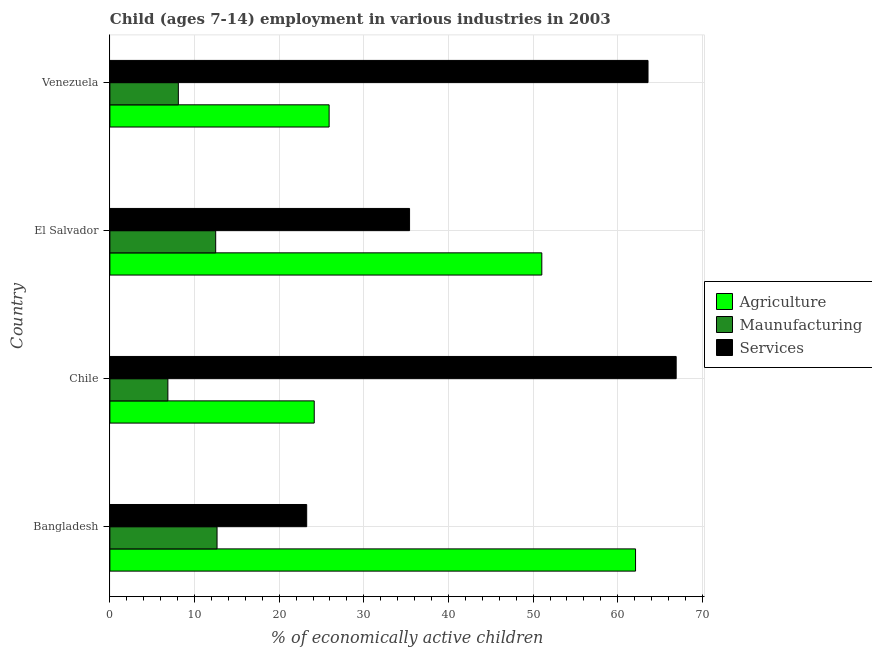Are the number of bars per tick equal to the number of legend labels?
Ensure brevity in your answer.  Yes. How many bars are there on the 4th tick from the top?
Your response must be concise. 3. How many bars are there on the 4th tick from the bottom?
Ensure brevity in your answer.  3. In how many cases, is the number of bars for a given country not equal to the number of legend labels?
Ensure brevity in your answer.  0. What is the percentage of economically active children in manufacturing in Bangladesh?
Give a very brief answer. 12.66. Across all countries, what is the maximum percentage of economically active children in services?
Make the answer very short. 66.9. Across all countries, what is the minimum percentage of economically active children in manufacturing?
Your answer should be compact. 6.85. In which country was the percentage of economically active children in agriculture minimum?
Ensure brevity in your answer.  Chile. What is the total percentage of economically active children in services in the graph?
Give a very brief answer. 189.13. What is the difference between the percentage of economically active children in agriculture in Bangladesh and that in Venezuela?
Offer a terse response. 36.2. What is the difference between the percentage of economically active children in agriculture in Venezuela and the percentage of economically active children in services in El Salvador?
Your answer should be compact. -9.5. What is the average percentage of economically active children in manufacturing per country?
Offer a very short reply. 10.02. What is the difference between the percentage of economically active children in agriculture and percentage of economically active children in manufacturing in El Salvador?
Your answer should be compact. 38.53. What is the ratio of the percentage of economically active children in services in Bangladesh to that in Chile?
Your answer should be compact. 0.35. Is the percentage of economically active children in agriculture in Chile less than that in Venezuela?
Make the answer very short. Yes. Is the difference between the percentage of economically active children in agriculture in Chile and El Salvador greater than the difference between the percentage of economically active children in services in Chile and El Salvador?
Your answer should be very brief. No. What is the difference between the highest and the second highest percentage of economically active children in services?
Make the answer very short. 3.33. What is the difference between the highest and the lowest percentage of economically active children in agriculture?
Give a very brief answer. 37.96. What does the 3rd bar from the top in Venezuela represents?
Your response must be concise. Agriculture. What does the 2nd bar from the bottom in El Salvador represents?
Your response must be concise. Maunufacturing. How many bars are there?
Your answer should be very brief. 12. Are all the bars in the graph horizontal?
Offer a terse response. Yes. Are the values on the major ticks of X-axis written in scientific E-notation?
Make the answer very short. No. Does the graph contain grids?
Your answer should be very brief. Yes. How are the legend labels stacked?
Give a very brief answer. Vertical. What is the title of the graph?
Provide a short and direct response. Child (ages 7-14) employment in various industries in 2003. Does "Transport" appear as one of the legend labels in the graph?
Provide a succinct answer. No. What is the label or title of the X-axis?
Keep it short and to the point. % of economically active children. What is the % of economically active children in Agriculture in Bangladesh?
Give a very brief answer. 62.1. What is the % of economically active children in Maunufacturing in Bangladesh?
Offer a very short reply. 12.66. What is the % of economically active children of Services in Bangladesh?
Make the answer very short. 23.25. What is the % of economically active children in Agriculture in Chile?
Provide a short and direct response. 24.14. What is the % of economically active children in Maunufacturing in Chile?
Provide a succinct answer. 6.85. What is the % of economically active children of Services in Chile?
Give a very brief answer. 66.9. What is the % of economically active children of Agriculture in El Salvador?
Provide a succinct answer. 51.03. What is the % of economically active children of Maunufacturing in El Salvador?
Your answer should be very brief. 12.5. What is the % of economically active children in Services in El Salvador?
Give a very brief answer. 35.4. What is the % of economically active children in Agriculture in Venezuela?
Provide a short and direct response. 25.9. What is the % of economically active children of Maunufacturing in Venezuela?
Your response must be concise. 8.09. What is the % of economically active children in Services in Venezuela?
Provide a short and direct response. 63.57. Across all countries, what is the maximum % of economically active children of Agriculture?
Your answer should be very brief. 62.1. Across all countries, what is the maximum % of economically active children in Maunufacturing?
Give a very brief answer. 12.66. Across all countries, what is the maximum % of economically active children of Services?
Your answer should be very brief. 66.9. Across all countries, what is the minimum % of economically active children in Agriculture?
Offer a terse response. 24.14. Across all countries, what is the minimum % of economically active children of Maunufacturing?
Your answer should be compact. 6.85. Across all countries, what is the minimum % of economically active children of Services?
Make the answer very short. 23.25. What is the total % of economically active children in Agriculture in the graph?
Offer a terse response. 163.17. What is the total % of economically active children of Maunufacturing in the graph?
Offer a very short reply. 40.1. What is the total % of economically active children in Services in the graph?
Offer a terse response. 189.13. What is the difference between the % of economically active children in Agriculture in Bangladesh and that in Chile?
Offer a very short reply. 37.96. What is the difference between the % of economically active children in Maunufacturing in Bangladesh and that in Chile?
Your response must be concise. 5.81. What is the difference between the % of economically active children of Services in Bangladesh and that in Chile?
Ensure brevity in your answer.  -43.65. What is the difference between the % of economically active children in Agriculture in Bangladesh and that in El Salvador?
Provide a succinct answer. 11.07. What is the difference between the % of economically active children of Maunufacturing in Bangladesh and that in El Salvador?
Ensure brevity in your answer.  0.16. What is the difference between the % of economically active children of Services in Bangladesh and that in El Salvador?
Provide a short and direct response. -12.15. What is the difference between the % of economically active children in Agriculture in Bangladesh and that in Venezuela?
Offer a terse response. 36.2. What is the difference between the % of economically active children of Maunufacturing in Bangladesh and that in Venezuela?
Your response must be concise. 4.57. What is the difference between the % of economically active children in Services in Bangladesh and that in Venezuela?
Offer a very short reply. -40.32. What is the difference between the % of economically active children of Agriculture in Chile and that in El Salvador?
Your response must be concise. -26.89. What is the difference between the % of economically active children in Maunufacturing in Chile and that in El Salvador?
Provide a succinct answer. -5.65. What is the difference between the % of economically active children of Services in Chile and that in El Salvador?
Provide a short and direct response. 31.5. What is the difference between the % of economically active children of Agriculture in Chile and that in Venezuela?
Keep it short and to the point. -1.76. What is the difference between the % of economically active children of Maunufacturing in Chile and that in Venezuela?
Make the answer very short. -1.24. What is the difference between the % of economically active children of Services in Chile and that in Venezuela?
Provide a succinct answer. 3.33. What is the difference between the % of economically active children in Agriculture in El Salvador and that in Venezuela?
Offer a terse response. 25.13. What is the difference between the % of economically active children in Maunufacturing in El Salvador and that in Venezuela?
Your answer should be very brief. 4.41. What is the difference between the % of economically active children in Services in El Salvador and that in Venezuela?
Provide a succinct answer. -28.17. What is the difference between the % of economically active children of Agriculture in Bangladesh and the % of economically active children of Maunufacturing in Chile?
Your answer should be compact. 55.25. What is the difference between the % of economically active children in Agriculture in Bangladesh and the % of economically active children in Services in Chile?
Keep it short and to the point. -4.8. What is the difference between the % of economically active children in Maunufacturing in Bangladesh and the % of economically active children in Services in Chile?
Offer a terse response. -54.24. What is the difference between the % of economically active children of Agriculture in Bangladesh and the % of economically active children of Maunufacturing in El Salvador?
Offer a very short reply. 49.6. What is the difference between the % of economically active children in Agriculture in Bangladesh and the % of economically active children in Services in El Salvador?
Provide a succinct answer. 26.7. What is the difference between the % of economically active children of Maunufacturing in Bangladesh and the % of economically active children of Services in El Salvador?
Give a very brief answer. -22.74. What is the difference between the % of economically active children of Agriculture in Bangladesh and the % of economically active children of Maunufacturing in Venezuela?
Give a very brief answer. 54.01. What is the difference between the % of economically active children of Agriculture in Bangladesh and the % of economically active children of Services in Venezuela?
Keep it short and to the point. -1.47. What is the difference between the % of economically active children in Maunufacturing in Bangladesh and the % of economically active children in Services in Venezuela?
Provide a succinct answer. -50.91. What is the difference between the % of economically active children in Agriculture in Chile and the % of economically active children in Maunufacturing in El Salvador?
Provide a succinct answer. 11.64. What is the difference between the % of economically active children of Agriculture in Chile and the % of economically active children of Services in El Salvador?
Provide a short and direct response. -11.26. What is the difference between the % of economically active children in Maunufacturing in Chile and the % of economically active children in Services in El Salvador?
Offer a very short reply. -28.55. What is the difference between the % of economically active children of Agriculture in Chile and the % of economically active children of Maunufacturing in Venezuela?
Your answer should be compact. 16.05. What is the difference between the % of economically active children in Agriculture in Chile and the % of economically active children in Services in Venezuela?
Ensure brevity in your answer.  -39.43. What is the difference between the % of economically active children in Maunufacturing in Chile and the % of economically active children in Services in Venezuela?
Offer a very short reply. -56.72. What is the difference between the % of economically active children in Agriculture in El Salvador and the % of economically active children in Maunufacturing in Venezuela?
Offer a very short reply. 42.94. What is the difference between the % of economically active children of Agriculture in El Salvador and the % of economically active children of Services in Venezuela?
Make the answer very short. -12.55. What is the difference between the % of economically active children of Maunufacturing in El Salvador and the % of economically active children of Services in Venezuela?
Give a very brief answer. -51.07. What is the average % of economically active children of Agriculture per country?
Provide a short and direct response. 40.79. What is the average % of economically active children of Maunufacturing per country?
Provide a short and direct response. 10.02. What is the average % of economically active children in Services per country?
Provide a short and direct response. 47.28. What is the difference between the % of economically active children of Agriculture and % of economically active children of Maunufacturing in Bangladesh?
Make the answer very short. 49.44. What is the difference between the % of economically active children in Agriculture and % of economically active children in Services in Bangladesh?
Make the answer very short. 38.85. What is the difference between the % of economically active children in Maunufacturing and % of economically active children in Services in Bangladesh?
Offer a very short reply. -10.59. What is the difference between the % of economically active children of Agriculture and % of economically active children of Maunufacturing in Chile?
Make the answer very short. 17.29. What is the difference between the % of economically active children in Agriculture and % of economically active children in Services in Chile?
Ensure brevity in your answer.  -42.76. What is the difference between the % of economically active children in Maunufacturing and % of economically active children in Services in Chile?
Your answer should be compact. -60.05. What is the difference between the % of economically active children in Agriculture and % of economically active children in Maunufacturing in El Salvador?
Your answer should be compact. 38.53. What is the difference between the % of economically active children of Agriculture and % of economically active children of Services in El Salvador?
Provide a succinct answer. 15.62. What is the difference between the % of economically active children of Maunufacturing and % of economically active children of Services in El Salvador?
Give a very brief answer. -22.9. What is the difference between the % of economically active children of Agriculture and % of economically active children of Maunufacturing in Venezuela?
Your answer should be very brief. 17.81. What is the difference between the % of economically active children in Agriculture and % of economically active children in Services in Venezuela?
Give a very brief answer. -37.67. What is the difference between the % of economically active children in Maunufacturing and % of economically active children in Services in Venezuela?
Your response must be concise. -55.49. What is the ratio of the % of economically active children in Agriculture in Bangladesh to that in Chile?
Provide a succinct answer. 2.57. What is the ratio of the % of economically active children of Maunufacturing in Bangladesh to that in Chile?
Offer a very short reply. 1.85. What is the ratio of the % of economically active children in Services in Bangladesh to that in Chile?
Offer a very short reply. 0.35. What is the ratio of the % of economically active children of Agriculture in Bangladesh to that in El Salvador?
Give a very brief answer. 1.22. What is the ratio of the % of economically active children in Maunufacturing in Bangladesh to that in El Salvador?
Your answer should be compact. 1.01. What is the ratio of the % of economically active children in Services in Bangladesh to that in El Salvador?
Provide a short and direct response. 0.66. What is the ratio of the % of economically active children in Agriculture in Bangladesh to that in Venezuela?
Offer a terse response. 2.4. What is the ratio of the % of economically active children of Maunufacturing in Bangladesh to that in Venezuela?
Keep it short and to the point. 1.57. What is the ratio of the % of economically active children in Services in Bangladesh to that in Venezuela?
Provide a short and direct response. 0.37. What is the ratio of the % of economically active children of Agriculture in Chile to that in El Salvador?
Make the answer very short. 0.47. What is the ratio of the % of economically active children in Maunufacturing in Chile to that in El Salvador?
Keep it short and to the point. 0.55. What is the ratio of the % of economically active children in Services in Chile to that in El Salvador?
Keep it short and to the point. 1.89. What is the ratio of the % of economically active children of Agriculture in Chile to that in Venezuela?
Give a very brief answer. 0.93. What is the ratio of the % of economically active children of Maunufacturing in Chile to that in Venezuela?
Offer a very short reply. 0.85. What is the ratio of the % of economically active children in Services in Chile to that in Venezuela?
Your answer should be compact. 1.05. What is the ratio of the % of economically active children of Agriculture in El Salvador to that in Venezuela?
Make the answer very short. 1.97. What is the ratio of the % of economically active children in Maunufacturing in El Salvador to that in Venezuela?
Make the answer very short. 1.55. What is the ratio of the % of economically active children of Services in El Salvador to that in Venezuela?
Provide a succinct answer. 0.56. What is the difference between the highest and the second highest % of economically active children in Agriculture?
Offer a terse response. 11.07. What is the difference between the highest and the second highest % of economically active children of Maunufacturing?
Your answer should be compact. 0.16. What is the difference between the highest and the second highest % of economically active children of Services?
Your answer should be very brief. 3.33. What is the difference between the highest and the lowest % of economically active children of Agriculture?
Your answer should be very brief. 37.96. What is the difference between the highest and the lowest % of economically active children in Maunufacturing?
Keep it short and to the point. 5.81. What is the difference between the highest and the lowest % of economically active children in Services?
Your answer should be very brief. 43.65. 